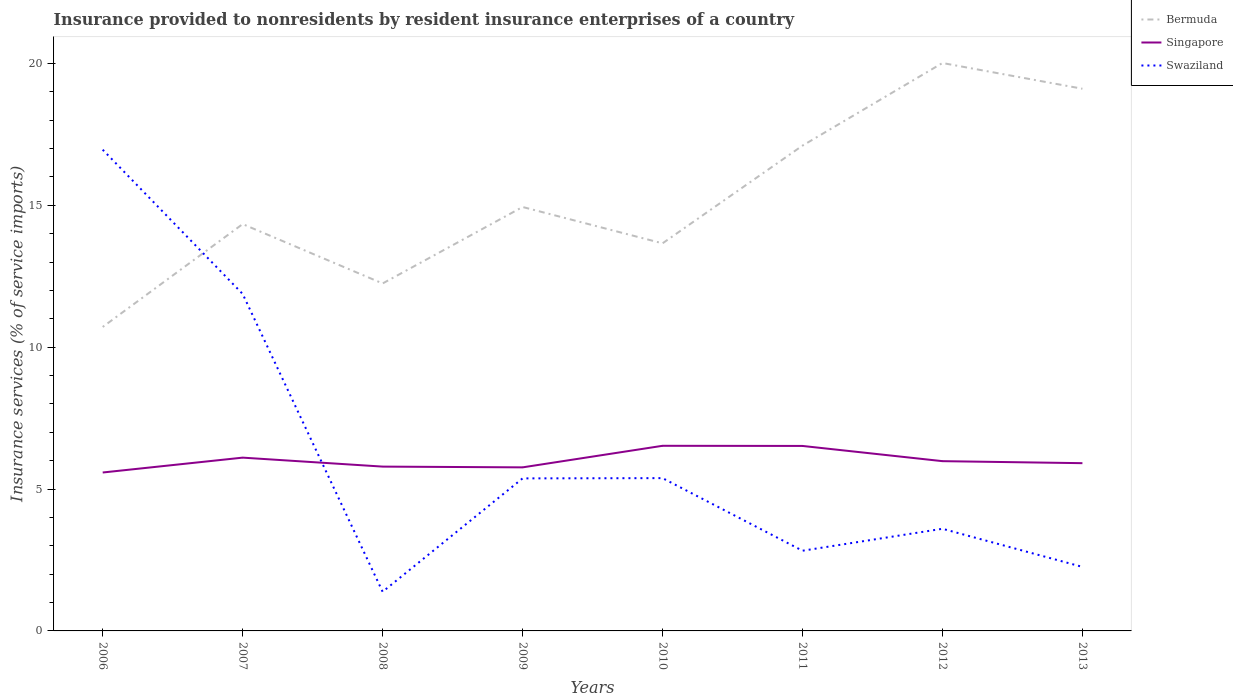Does the line corresponding to Singapore intersect with the line corresponding to Bermuda?
Offer a very short reply. No. Across all years, what is the maximum insurance provided to nonresidents in Singapore?
Offer a very short reply. 5.58. In which year was the insurance provided to nonresidents in Bermuda maximum?
Keep it short and to the point. 2006. What is the total insurance provided to nonresidents in Swaziland in the graph?
Provide a short and direct response. 2.56. What is the difference between the highest and the second highest insurance provided to nonresidents in Singapore?
Offer a very short reply. 0.94. What is the difference between the highest and the lowest insurance provided to nonresidents in Swaziland?
Your response must be concise. 2. How many lines are there?
Make the answer very short. 3. How many years are there in the graph?
Provide a succinct answer. 8. How many legend labels are there?
Your answer should be very brief. 3. How are the legend labels stacked?
Offer a very short reply. Vertical. What is the title of the graph?
Your response must be concise. Insurance provided to nonresidents by resident insurance enterprises of a country. What is the label or title of the X-axis?
Give a very brief answer. Years. What is the label or title of the Y-axis?
Your answer should be compact. Insurance services (% of service imports). What is the Insurance services (% of service imports) of Bermuda in 2006?
Keep it short and to the point. 10.71. What is the Insurance services (% of service imports) of Singapore in 2006?
Give a very brief answer. 5.58. What is the Insurance services (% of service imports) of Swaziland in 2006?
Your answer should be compact. 16.96. What is the Insurance services (% of service imports) in Bermuda in 2007?
Provide a succinct answer. 14.34. What is the Insurance services (% of service imports) of Singapore in 2007?
Keep it short and to the point. 6.11. What is the Insurance services (% of service imports) of Swaziland in 2007?
Offer a very short reply. 11.88. What is the Insurance services (% of service imports) in Bermuda in 2008?
Your answer should be very brief. 12.25. What is the Insurance services (% of service imports) in Singapore in 2008?
Keep it short and to the point. 5.79. What is the Insurance services (% of service imports) of Swaziland in 2008?
Offer a very short reply. 1.38. What is the Insurance services (% of service imports) in Bermuda in 2009?
Offer a terse response. 14.94. What is the Insurance services (% of service imports) in Singapore in 2009?
Your answer should be very brief. 5.76. What is the Insurance services (% of service imports) in Swaziland in 2009?
Provide a short and direct response. 5.38. What is the Insurance services (% of service imports) of Bermuda in 2010?
Give a very brief answer. 13.66. What is the Insurance services (% of service imports) in Singapore in 2010?
Your response must be concise. 6.52. What is the Insurance services (% of service imports) of Swaziland in 2010?
Offer a very short reply. 5.38. What is the Insurance services (% of service imports) in Bermuda in 2011?
Your response must be concise. 17.1. What is the Insurance services (% of service imports) of Singapore in 2011?
Your response must be concise. 6.52. What is the Insurance services (% of service imports) in Swaziland in 2011?
Your answer should be very brief. 2.83. What is the Insurance services (% of service imports) of Bermuda in 2012?
Your response must be concise. 20.02. What is the Insurance services (% of service imports) in Singapore in 2012?
Give a very brief answer. 5.98. What is the Insurance services (% of service imports) of Swaziland in 2012?
Ensure brevity in your answer.  3.6. What is the Insurance services (% of service imports) of Bermuda in 2013?
Your answer should be compact. 19.11. What is the Insurance services (% of service imports) in Singapore in 2013?
Provide a succinct answer. 5.91. What is the Insurance services (% of service imports) in Swaziland in 2013?
Give a very brief answer. 2.26. Across all years, what is the maximum Insurance services (% of service imports) of Bermuda?
Ensure brevity in your answer.  20.02. Across all years, what is the maximum Insurance services (% of service imports) of Singapore?
Provide a succinct answer. 6.52. Across all years, what is the maximum Insurance services (% of service imports) of Swaziland?
Give a very brief answer. 16.96. Across all years, what is the minimum Insurance services (% of service imports) in Bermuda?
Keep it short and to the point. 10.71. Across all years, what is the minimum Insurance services (% of service imports) in Singapore?
Your response must be concise. 5.58. Across all years, what is the minimum Insurance services (% of service imports) in Swaziland?
Ensure brevity in your answer.  1.38. What is the total Insurance services (% of service imports) in Bermuda in the graph?
Provide a short and direct response. 122.13. What is the total Insurance services (% of service imports) of Singapore in the graph?
Provide a succinct answer. 48.19. What is the total Insurance services (% of service imports) in Swaziland in the graph?
Keep it short and to the point. 49.66. What is the difference between the Insurance services (% of service imports) in Bermuda in 2006 and that in 2007?
Offer a very short reply. -3.62. What is the difference between the Insurance services (% of service imports) in Singapore in 2006 and that in 2007?
Your response must be concise. -0.52. What is the difference between the Insurance services (% of service imports) of Swaziland in 2006 and that in 2007?
Your response must be concise. 5.08. What is the difference between the Insurance services (% of service imports) in Bermuda in 2006 and that in 2008?
Keep it short and to the point. -1.53. What is the difference between the Insurance services (% of service imports) of Singapore in 2006 and that in 2008?
Your response must be concise. -0.21. What is the difference between the Insurance services (% of service imports) of Swaziland in 2006 and that in 2008?
Offer a very short reply. 15.58. What is the difference between the Insurance services (% of service imports) of Bermuda in 2006 and that in 2009?
Provide a succinct answer. -4.23. What is the difference between the Insurance services (% of service imports) in Singapore in 2006 and that in 2009?
Your response must be concise. -0.18. What is the difference between the Insurance services (% of service imports) of Swaziland in 2006 and that in 2009?
Your answer should be very brief. 11.58. What is the difference between the Insurance services (% of service imports) of Bermuda in 2006 and that in 2010?
Offer a very short reply. -2.95. What is the difference between the Insurance services (% of service imports) of Singapore in 2006 and that in 2010?
Make the answer very short. -0.94. What is the difference between the Insurance services (% of service imports) in Swaziland in 2006 and that in 2010?
Your answer should be very brief. 11.57. What is the difference between the Insurance services (% of service imports) in Bermuda in 2006 and that in 2011?
Provide a short and direct response. -6.39. What is the difference between the Insurance services (% of service imports) in Singapore in 2006 and that in 2011?
Make the answer very short. -0.94. What is the difference between the Insurance services (% of service imports) in Swaziland in 2006 and that in 2011?
Ensure brevity in your answer.  14.13. What is the difference between the Insurance services (% of service imports) in Bermuda in 2006 and that in 2012?
Your answer should be very brief. -9.3. What is the difference between the Insurance services (% of service imports) in Singapore in 2006 and that in 2012?
Your answer should be very brief. -0.4. What is the difference between the Insurance services (% of service imports) in Swaziland in 2006 and that in 2012?
Make the answer very short. 13.36. What is the difference between the Insurance services (% of service imports) in Bermuda in 2006 and that in 2013?
Offer a very short reply. -8.4. What is the difference between the Insurance services (% of service imports) in Singapore in 2006 and that in 2013?
Provide a succinct answer. -0.33. What is the difference between the Insurance services (% of service imports) of Swaziland in 2006 and that in 2013?
Your response must be concise. 14.7. What is the difference between the Insurance services (% of service imports) in Bermuda in 2007 and that in 2008?
Give a very brief answer. 2.09. What is the difference between the Insurance services (% of service imports) of Singapore in 2007 and that in 2008?
Your answer should be compact. 0.32. What is the difference between the Insurance services (% of service imports) of Swaziland in 2007 and that in 2008?
Provide a short and direct response. 10.5. What is the difference between the Insurance services (% of service imports) in Bermuda in 2007 and that in 2009?
Offer a very short reply. -0.6. What is the difference between the Insurance services (% of service imports) of Singapore in 2007 and that in 2009?
Your answer should be very brief. 0.34. What is the difference between the Insurance services (% of service imports) of Swaziland in 2007 and that in 2009?
Provide a succinct answer. 6.5. What is the difference between the Insurance services (% of service imports) of Bermuda in 2007 and that in 2010?
Offer a terse response. 0.68. What is the difference between the Insurance services (% of service imports) of Singapore in 2007 and that in 2010?
Your response must be concise. -0.42. What is the difference between the Insurance services (% of service imports) in Swaziland in 2007 and that in 2010?
Offer a terse response. 6.49. What is the difference between the Insurance services (% of service imports) in Bermuda in 2007 and that in 2011?
Give a very brief answer. -2.77. What is the difference between the Insurance services (% of service imports) of Singapore in 2007 and that in 2011?
Offer a terse response. -0.41. What is the difference between the Insurance services (% of service imports) in Swaziland in 2007 and that in 2011?
Offer a terse response. 9.05. What is the difference between the Insurance services (% of service imports) in Bermuda in 2007 and that in 2012?
Give a very brief answer. -5.68. What is the difference between the Insurance services (% of service imports) of Singapore in 2007 and that in 2012?
Make the answer very short. 0.12. What is the difference between the Insurance services (% of service imports) of Swaziland in 2007 and that in 2012?
Your answer should be compact. 8.28. What is the difference between the Insurance services (% of service imports) in Bermuda in 2007 and that in 2013?
Offer a very short reply. -4.77. What is the difference between the Insurance services (% of service imports) in Singapore in 2007 and that in 2013?
Your answer should be very brief. 0.2. What is the difference between the Insurance services (% of service imports) of Swaziland in 2007 and that in 2013?
Provide a short and direct response. 9.62. What is the difference between the Insurance services (% of service imports) of Bermuda in 2008 and that in 2009?
Offer a very short reply. -2.7. What is the difference between the Insurance services (% of service imports) of Singapore in 2008 and that in 2009?
Ensure brevity in your answer.  0.03. What is the difference between the Insurance services (% of service imports) of Swaziland in 2008 and that in 2009?
Provide a succinct answer. -4. What is the difference between the Insurance services (% of service imports) of Bermuda in 2008 and that in 2010?
Offer a terse response. -1.41. What is the difference between the Insurance services (% of service imports) of Singapore in 2008 and that in 2010?
Offer a terse response. -0.73. What is the difference between the Insurance services (% of service imports) of Swaziland in 2008 and that in 2010?
Give a very brief answer. -4. What is the difference between the Insurance services (% of service imports) in Bermuda in 2008 and that in 2011?
Provide a short and direct response. -4.86. What is the difference between the Insurance services (% of service imports) in Singapore in 2008 and that in 2011?
Make the answer very short. -0.73. What is the difference between the Insurance services (% of service imports) in Swaziland in 2008 and that in 2011?
Your answer should be compact. -1.45. What is the difference between the Insurance services (% of service imports) in Bermuda in 2008 and that in 2012?
Provide a succinct answer. -7.77. What is the difference between the Insurance services (% of service imports) in Singapore in 2008 and that in 2012?
Your response must be concise. -0.19. What is the difference between the Insurance services (% of service imports) in Swaziland in 2008 and that in 2012?
Ensure brevity in your answer.  -2.22. What is the difference between the Insurance services (% of service imports) of Bermuda in 2008 and that in 2013?
Ensure brevity in your answer.  -6.86. What is the difference between the Insurance services (% of service imports) in Singapore in 2008 and that in 2013?
Your answer should be compact. -0.12. What is the difference between the Insurance services (% of service imports) of Swaziland in 2008 and that in 2013?
Make the answer very short. -0.88. What is the difference between the Insurance services (% of service imports) of Bermuda in 2009 and that in 2010?
Provide a short and direct response. 1.28. What is the difference between the Insurance services (% of service imports) of Singapore in 2009 and that in 2010?
Offer a terse response. -0.76. What is the difference between the Insurance services (% of service imports) of Swaziland in 2009 and that in 2010?
Offer a very short reply. -0.01. What is the difference between the Insurance services (% of service imports) of Bermuda in 2009 and that in 2011?
Your answer should be compact. -2.16. What is the difference between the Insurance services (% of service imports) in Singapore in 2009 and that in 2011?
Your response must be concise. -0.75. What is the difference between the Insurance services (% of service imports) of Swaziland in 2009 and that in 2011?
Offer a terse response. 2.55. What is the difference between the Insurance services (% of service imports) of Bermuda in 2009 and that in 2012?
Offer a terse response. -5.07. What is the difference between the Insurance services (% of service imports) of Singapore in 2009 and that in 2012?
Your answer should be compact. -0.22. What is the difference between the Insurance services (% of service imports) in Swaziland in 2009 and that in 2012?
Your answer should be very brief. 1.78. What is the difference between the Insurance services (% of service imports) in Bermuda in 2009 and that in 2013?
Make the answer very short. -4.17. What is the difference between the Insurance services (% of service imports) in Singapore in 2009 and that in 2013?
Keep it short and to the point. -0.15. What is the difference between the Insurance services (% of service imports) of Swaziland in 2009 and that in 2013?
Offer a terse response. 3.12. What is the difference between the Insurance services (% of service imports) of Bermuda in 2010 and that in 2011?
Provide a short and direct response. -3.44. What is the difference between the Insurance services (% of service imports) of Singapore in 2010 and that in 2011?
Provide a short and direct response. 0.01. What is the difference between the Insurance services (% of service imports) of Swaziland in 2010 and that in 2011?
Ensure brevity in your answer.  2.56. What is the difference between the Insurance services (% of service imports) in Bermuda in 2010 and that in 2012?
Offer a terse response. -6.36. What is the difference between the Insurance services (% of service imports) in Singapore in 2010 and that in 2012?
Your response must be concise. 0.54. What is the difference between the Insurance services (% of service imports) in Swaziland in 2010 and that in 2012?
Provide a short and direct response. 1.78. What is the difference between the Insurance services (% of service imports) in Bermuda in 2010 and that in 2013?
Offer a very short reply. -5.45. What is the difference between the Insurance services (% of service imports) in Singapore in 2010 and that in 2013?
Ensure brevity in your answer.  0.61. What is the difference between the Insurance services (% of service imports) of Swaziland in 2010 and that in 2013?
Ensure brevity in your answer.  3.13. What is the difference between the Insurance services (% of service imports) in Bermuda in 2011 and that in 2012?
Your answer should be very brief. -2.91. What is the difference between the Insurance services (% of service imports) in Singapore in 2011 and that in 2012?
Provide a succinct answer. 0.54. What is the difference between the Insurance services (% of service imports) in Swaziland in 2011 and that in 2012?
Provide a succinct answer. -0.77. What is the difference between the Insurance services (% of service imports) of Bermuda in 2011 and that in 2013?
Offer a very short reply. -2. What is the difference between the Insurance services (% of service imports) of Singapore in 2011 and that in 2013?
Your answer should be very brief. 0.61. What is the difference between the Insurance services (% of service imports) of Swaziland in 2011 and that in 2013?
Offer a very short reply. 0.57. What is the difference between the Insurance services (% of service imports) of Bermuda in 2012 and that in 2013?
Ensure brevity in your answer.  0.91. What is the difference between the Insurance services (% of service imports) of Singapore in 2012 and that in 2013?
Your answer should be very brief. 0.07. What is the difference between the Insurance services (% of service imports) in Swaziland in 2012 and that in 2013?
Offer a terse response. 1.34. What is the difference between the Insurance services (% of service imports) of Bermuda in 2006 and the Insurance services (% of service imports) of Singapore in 2007?
Provide a succinct answer. 4.61. What is the difference between the Insurance services (% of service imports) in Bermuda in 2006 and the Insurance services (% of service imports) in Swaziland in 2007?
Your response must be concise. -1.16. What is the difference between the Insurance services (% of service imports) in Singapore in 2006 and the Insurance services (% of service imports) in Swaziland in 2007?
Your response must be concise. -6.29. What is the difference between the Insurance services (% of service imports) in Bermuda in 2006 and the Insurance services (% of service imports) in Singapore in 2008?
Provide a short and direct response. 4.92. What is the difference between the Insurance services (% of service imports) in Bermuda in 2006 and the Insurance services (% of service imports) in Swaziland in 2008?
Keep it short and to the point. 9.33. What is the difference between the Insurance services (% of service imports) of Singapore in 2006 and the Insurance services (% of service imports) of Swaziland in 2008?
Make the answer very short. 4.2. What is the difference between the Insurance services (% of service imports) of Bermuda in 2006 and the Insurance services (% of service imports) of Singapore in 2009?
Provide a short and direct response. 4.95. What is the difference between the Insurance services (% of service imports) of Bermuda in 2006 and the Insurance services (% of service imports) of Swaziland in 2009?
Offer a terse response. 5.34. What is the difference between the Insurance services (% of service imports) in Singapore in 2006 and the Insurance services (% of service imports) in Swaziland in 2009?
Ensure brevity in your answer.  0.21. What is the difference between the Insurance services (% of service imports) in Bermuda in 2006 and the Insurance services (% of service imports) in Singapore in 2010?
Your answer should be compact. 4.19. What is the difference between the Insurance services (% of service imports) in Bermuda in 2006 and the Insurance services (% of service imports) in Swaziland in 2010?
Provide a short and direct response. 5.33. What is the difference between the Insurance services (% of service imports) in Singapore in 2006 and the Insurance services (% of service imports) in Swaziland in 2010?
Ensure brevity in your answer.  0.2. What is the difference between the Insurance services (% of service imports) of Bermuda in 2006 and the Insurance services (% of service imports) of Singapore in 2011?
Your answer should be very brief. 4.19. What is the difference between the Insurance services (% of service imports) of Bermuda in 2006 and the Insurance services (% of service imports) of Swaziland in 2011?
Offer a very short reply. 7.89. What is the difference between the Insurance services (% of service imports) of Singapore in 2006 and the Insurance services (% of service imports) of Swaziland in 2011?
Your answer should be compact. 2.76. What is the difference between the Insurance services (% of service imports) of Bermuda in 2006 and the Insurance services (% of service imports) of Singapore in 2012?
Provide a short and direct response. 4.73. What is the difference between the Insurance services (% of service imports) in Bermuda in 2006 and the Insurance services (% of service imports) in Swaziland in 2012?
Make the answer very short. 7.11. What is the difference between the Insurance services (% of service imports) of Singapore in 2006 and the Insurance services (% of service imports) of Swaziland in 2012?
Give a very brief answer. 1.98. What is the difference between the Insurance services (% of service imports) in Bermuda in 2006 and the Insurance services (% of service imports) in Singapore in 2013?
Your answer should be very brief. 4.8. What is the difference between the Insurance services (% of service imports) in Bermuda in 2006 and the Insurance services (% of service imports) in Swaziland in 2013?
Provide a short and direct response. 8.46. What is the difference between the Insurance services (% of service imports) in Singapore in 2006 and the Insurance services (% of service imports) in Swaziland in 2013?
Make the answer very short. 3.33. What is the difference between the Insurance services (% of service imports) in Bermuda in 2007 and the Insurance services (% of service imports) in Singapore in 2008?
Provide a succinct answer. 8.55. What is the difference between the Insurance services (% of service imports) of Bermuda in 2007 and the Insurance services (% of service imports) of Swaziland in 2008?
Make the answer very short. 12.96. What is the difference between the Insurance services (% of service imports) of Singapore in 2007 and the Insurance services (% of service imports) of Swaziland in 2008?
Offer a very short reply. 4.73. What is the difference between the Insurance services (% of service imports) of Bermuda in 2007 and the Insurance services (% of service imports) of Singapore in 2009?
Offer a terse response. 8.57. What is the difference between the Insurance services (% of service imports) of Bermuda in 2007 and the Insurance services (% of service imports) of Swaziland in 2009?
Provide a succinct answer. 8.96. What is the difference between the Insurance services (% of service imports) of Singapore in 2007 and the Insurance services (% of service imports) of Swaziland in 2009?
Your answer should be compact. 0.73. What is the difference between the Insurance services (% of service imports) in Bermuda in 2007 and the Insurance services (% of service imports) in Singapore in 2010?
Offer a very short reply. 7.81. What is the difference between the Insurance services (% of service imports) in Bermuda in 2007 and the Insurance services (% of service imports) in Swaziland in 2010?
Ensure brevity in your answer.  8.95. What is the difference between the Insurance services (% of service imports) of Singapore in 2007 and the Insurance services (% of service imports) of Swaziland in 2010?
Your answer should be compact. 0.72. What is the difference between the Insurance services (% of service imports) of Bermuda in 2007 and the Insurance services (% of service imports) of Singapore in 2011?
Give a very brief answer. 7.82. What is the difference between the Insurance services (% of service imports) in Bermuda in 2007 and the Insurance services (% of service imports) in Swaziland in 2011?
Offer a terse response. 11.51. What is the difference between the Insurance services (% of service imports) of Singapore in 2007 and the Insurance services (% of service imports) of Swaziland in 2011?
Keep it short and to the point. 3.28. What is the difference between the Insurance services (% of service imports) of Bermuda in 2007 and the Insurance services (% of service imports) of Singapore in 2012?
Ensure brevity in your answer.  8.36. What is the difference between the Insurance services (% of service imports) in Bermuda in 2007 and the Insurance services (% of service imports) in Swaziland in 2012?
Provide a succinct answer. 10.74. What is the difference between the Insurance services (% of service imports) in Singapore in 2007 and the Insurance services (% of service imports) in Swaziland in 2012?
Your answer should be very brief. 2.51. What is the difference between the Insurance services (% of service imports) in Bermuda in 2007 and the Insurance services (% of service imports) in Singapore in 2013?
Make the answer very short. 8.43. What is the difference between the Insurance services (% of service imports) in Bermuda in 2007 and the Insurance services (% of service imports) in Swaziland in 2013?
Offer a terse response. 12.08. What is the difference between the Insurance services (% of service imports) of Singapore in 2007 and the Insurance services (% of service imports) of Swaziland in 2013?
Your answer should be very brief. 3.85. What is the difference between the Insurance services (% of service imports) of Bermuda in 2008 and the Insurance services (% of service imports) of Singapore in 2009?
Offer a very short reply. 6.48. What is the difference between the Insurance services (% of service imports) of Bermuda in 2008 and the Insurance services (% of service imports) of Swaziland in 2009?
Provide a short and direct response. 6.87. What is the difference between the Insurance services (% of service imports) of Singapore in 2008 and the Insurance services (% of service imports) of Swaziland in 2009?
Provide a succinct answer. 0.42. What is the difference between the Insurance services (% of service imports) in Bermuda in 2008 and the Insurance services (% of service imports) in Singapore in 2010?
Your response must be concise. 5.72. What is the difference between the Insurance services (% of service imports) of Bermuda in 2008 and the Insurance services (% of service imports) of Swaziland in 2010?
Keep it short and to the point. 6.86. What is the difference between the Insurance services (% of service imports) of Singapore in 2008 and the Insurance services (% of service imports) of Swaziland in 2010?
Ensure brevity in your answer.  0.41. What is the difference between the Insurance services (% of service imports) in Bermuda in 2008 and the Insurance services (% of service imports) in Singapore in 2011?
Your response must be concise. 5.73. What is the difference between the Insurance services (% of service imports) in Bermuda in 2008 and the Insurance services (% of service imports) in Swaziland in 2011?
Provide a short and direct response. 9.42. What is the difference between the Insurance services (% of service imports) in Singapore in 2008 and the Insurance services (% of service imports) in Swaziland in 2011?
Provide a succinct answer. 2.96. What is the difference between the Insurance services (% of service imports) of Bermuda in 2008 and the Insurance services (% of service imports) of Singapore in 2012?
Provide a succinct answer. 6.26. What is the difference between the Insurance services (% of service imports) of Bermuda in 2008 and the Insurance services (% of service imports) of Swaziland in 2012?
Make the answer very short. 8.65. What is the difference between the Insurance services (% of service imports) in Singapore in 2008 and the Insurance services (% of service imports) in Swaziland in 2012?
Ensure brevity in your answer.  2.19. What is the difference between the Insurance services (% of service imports) of Bermuda in 2008 and the Insurance services (% of service imports) of Singapore in 2013?
Give a very brief answer. 6.33. What is the difference between the Insurance services (% of service imports) in Bermuda in 2008 and the Insurance services (% of service imports) in Swaziland in 2013?
Give a very brief answer. 9.99. What is the difference between the Insurance services (% of service imports) in Singapore in 2008 and the Insurance services (% of service imports) in Swaziland in 2013?
Provide a succinct answer. 3.53. What is the difference between the Insurance services (% of service imports) in Bermuda in 2009 and the Insurance services (% of service imports) in Singapore in 2010?
Provide a succinct answer. 8.42. What is the difference between the Insurance services (% of service imports) of Bermuda in 2009 and the Insurance services (% of service imports) of Swaziland in 2010?
Your answer should be very brief. 9.56. What is the difference between the Insurance services (% of service imports) of Singapore in 2009 and the Insurance services (% of service imports) of Swaziland in 2010?
Offer a very short reply. 0.38. What is the difference between the Insurance services (% of service imports) of Bermuda in 2009 and the Insurance services (% of service imports) of Singapore in 2011?
Provide a short and direct response. 8.42. What is the difference between the Insurance services (% of service imports) in Bermuda in 2009 and the Insurance services (% of service imports) in Swaziland in 2011?
Your answer should be very brief. 12.11. What is the difference between the Insurance services (% of service imports) of Singapore in 2009 and the Insurance services (% of service imports) of Swaziland in 2011?
Make the answer very short. 2.94. What is the difference between the Insurance services (% of service imports) in Bermuda in 2009 and the Insurance services (% of service imports) in Singapore in 2012?
Offer a very short reply. 8.96. What is the difference between the Insurance services (% of service imports) of Bermuda in 2009 and the Insurance services (% of service imports) of Swaziland in 2012?
Keep it short and to the point. 11.34. What is the difference between the Insurance services (% of service imports) of Singapore in 2009 and the Insurance services (% of service imports) of Swaziland in 2012?
Offer a terse response. 2.16. What is the difference between the Insurance services (% of service imports) of Bermuda in 2009 and the Insurance services (% of service imports) of Singapore in 2013?
Ensure brevity in your answer.  9.03. What is the difference between the Insurance services (% of service imports) in Bermuda in 2009 and the Insurance services (% of service imports) in Swaziland in 2013?
Your answer should be very brief. 12.68. What is the difference between the Insurance services (% of service imports) of Singapore in 2009 and the Insurance services (% of service imports) of Swaziland in 2013?
Ensure brevity in your answer.  3.51. What is the difference between the Insurance services (% of service imports) of Bermuda in 2010 and the Insurance services (% of service imports) of Singapore in 2011?
Give a very brief answer. 7.14. What is the difference between the Insurance services (% of service imports) in Bermuda in 2010 and the Insurance services (% of service imports) in Swaziland in 2011?
Give a very brief answer. 10.83. What is the difference between the Insurance services (% of service imports) in Singapore in 2010 and the Insurance services (% of service imports) in Swaziland in 2011?
Offer a terse response. 3.7. What is the difference between the Insurance services (% of service imports) in Bermuda in 2010 and the Insurance services (% of service imports) in Singapore in 2012?
Your response must be concise. 7.68. What is the difference between the Insurance services (% of service imports) of Bermuda in 2010 and the Insurance services (% of service imports) of Swaziland in 2012?
Your answer should be compact. 10.06. What is the difference between the Insurance services (% of service imports) in Singapore in 2010 and the Insurance services (% of service imports) in Swaziland in 2012?
Provide a short and direct response. 2.92. What is the difference between the Insurance services (% of service imports) of Bermuda in 2010 and the Insurance services (% of service imports) of Singapore in 2013?
Keep it short and to the point. 7.75. What is the difference between the Insurance services (% of service imports) in Bermuda in 2010 and the Insurance services (% of service imports) in Swaziland in 2013?
Provide a succinct answer. 11.4. What is the difference between the Insurance services (% of service imports) in Singapore in 2010 and the Insurance services (% of service imports) in Swaziland in 2013?
Your response must be concise. 4.27. What is the difference between the Insurance services (% of service imports) of Bermuda in 2011 and the Insurance services (% of service imports) of Singapore in 2012?
Your answer should be compact. 11.12. What is the difference between the Insurance services (% of service imports) of Bermuda in 2011 and the Insurance services (% of service imports) of Swaziland in 2012?
Your response must be concise. 13.5. What is the difference between the Insurance services (% of service imports) in Singapore in 2011 and the Insurance services (% of service imports) in Swaziland in 2012?
Your answer should be very brief. 2.92. What is the difference between the Insurance services (% of service imports) in Bermuda in 2011 and the Insurance services (% of service imports) in Singapore in 2013?
Your answer should be very brief. 11.19. What is the difference between the Insurance services (% of service imports) of Bermuda in 2011 and the Insurance services (% of service imports) of Swaziland in 2013?
Offer a very short reply. 14.85. What is the difference between the Insurance services (% of service imports) of Singapore in 2011 and the Insurance services (% of service imports) of Swaziland in 2013?
Your response must be concise. 4.26. What is the difference between the Insurance services (% of service imports) in Bermuda in 2012 and the Insurance services (% of service imports) in Singapore in 2013?
Your answer should be very brief. 14.1. What is the difference between the Insurance services (% of service imports) in Bermuda in 2012 and the Insurance services (% of service imports) in Swaziland in 2013?
Your answer should be compact. 17.76. What is the difference between the Insurance services (% of service imports) of Singapore in 2012 and the Insurance services (% of service imports) of Swaziland in 2013?
Make the answer very short. 3.73. What is the average Insurance services (% of service imports) of Bermuda per year?
Your response must be concise. 15.27. What is the average Insurance services (% of service imports) of Singapore per year?
Offer a terse response. 6.02. What is the average Insurance services (% of service imports) of Swaziland per year?
Your response must be concise. 6.21. In the year 2006, what is the difference between the Insurance services (% of service imports) in Bermuda and Insurance services (% of service imports) in Singapore?
Provide a short and direct response. 5.13. In the year 2006, what is the difference between the Insurance services (% of service imports) in Bermuda and Insurance services (% of service imports) in Swaziland?
Your answer should be very brief. -6.25. In the year 2006, what is the difference between the Insurance services (% of service imports) in Singapore and Insurance services (% of service imports) in Swaziland?
Your response must be concise. -11.38. In the year 2007, what is the difference between the Insurance services (% of service imports) of Bermuda and Insurance services (% of service imports) of Singapore?
Your answer should be compact. 8.23. In the year 2007, what is the difference between the Insurance services (% of service imports) of Bermuda and Insurance services (% of service imports) of Swaziland?
Your answer should be very brief. 2.46. In the year 2007, what is the difference between the Insurance services (% of service imports) of Singapore and Insurance services (% of service imports) of Swaziland?
Your answer should be compact. -5.77. In the year 2008, what is the difference between the Insurance services (% of service imports) of Bermuda and Insurance services (% of service imports) of Singapore?
Your response must be concise. 6.45. In the year 2008, what is the difference between the Insurance services (% of service imports) of Bermuda and Insurance services (% of service imports) of Swaziland?
Give a very brief answer. 10.87. In the year 2008, what is the difference between the Insurance services (% of service imports) of Singapore and Insurance services (% of service imports) of Swaziland?
Offer a very short reply. 4.41. In the year 2009, what is the difference between the Insurance services (% of service imports) in Bermuda and Insurance services (% of service imports) in Singapore?
Offer a terse response. 9.18. In the year 2009, what is the difference between the Insurance services (% of service imports) of Bermuda and Insurance services (% of service imports) of Swaziland?
Your answer should be very brief. 9.57. In the year 2009, what is the difference between the Insurance services (% of service imports) of Singapore and Insurance services (% of service imports) of Swaziland?
Ensure brevity in your answer.  0.39. In the year 2010, what is the difference between the Insurance services (% of service imports) of Bermuda and Insurance services (% of service imports) of Singapore?
Provide a short and direct response. 7.14. In the year 2010, what is the difference between the Insurance services (% of service imports) in Bermuda and Insurance services (% of service imports) in Swaziland?
Provide a short and direct response. 8.28. In the year 2010, what is the difference between the Insurance services (% of service imports) of Singapore and Insurance services (% of service imports) of Swaziland?
Your response must be concise. 1.14. In the year 2011, what is the difference between the Insurance services (% of service imports) of Bermuda and Insurance services (% of service imports) of Singapore?
Ensure brevity in your answer.  10.58. In the year 2011, what is the difference between the Insurance services (% of service imports) of Bermuda and Insurance services (% of service imports) of Swaziland?
Offer a very short reply. 14.28. In the year 2011, what is the difference between the Insurance services (% of service imports) in Singapore and Insurance services (% of service imports) in Swaziland?
Make the answer very short. 3.69. In the year 2012, what is the difference between the Insurance services (% of service imports) of Bermuda and Insurance services (% of service imports) of Singapore?
Keep it short and to the point. 14.03. In the year 2012, what is the difference between the Insurance services (% of service imports) of Bermuda and Insurance services (% of service imports) of Swaziland?
Keep it short and to the point. 16.41. In the year 2012, what is the difference between the Insurance services (% of service imports) in Singapore and Insurance services (% of service imports) in Swaziland?
Provide a succinct answer. 2.38. In the year 2013, what is the difference between the Insurance services (% of service imports) of Bermuda and Insurance services (% of service imports) of Singapore?
Offer a terse response. 13.2. In the year 2013, what is the difference between the Insurance services (% of service imports) in Bermuda and Insurance services (% of service imports) in Swaziland?
Offer a terse response. 16.85. In the year 2013, what is the difference between the Insurance services (% of service imports) in Singapore and Insurance services (% of service imports) in Swaziland?
Keep it short and to the point. 3.66. What is the ratio of the Insurance services (% of service imports) of Bermuda in 2006 to that in 2007?
Give a very brief answer. 0.75. What is the ratio of the Insurance services (% of service imports) of Singapore in 2006 to that in 2007?
Keep it short and to the point. 0.91. What is the ratio of the Insurance services (% of service imports) in Swaziland in 2006 to that in 2007?
Make the answer very short. 1.43. What is the ratio of the Insurance services (% of service imports) in Bermuda in 2006 to that in 2008?
Provide a short and direct response. 0.87. What is the ratio of the Insurance services (% of service imports) in Singapore in 2006 to that in 2008?
Keep it short and to the point. 0.96. What is the ratio of the Insurance services (% of service imports) in Swaziland in 2006 to that in 2008?
Offer a terse response. 12.29. What is the ratio of the Insurance services (% of service imports) of Bermuda in 2006 to that in 2009?
Offer a very short reply. 0.72. What is the ratio of the Insurance services (% of service imports) of Singapore in 2006 to that in 2009?
Your answer should be compact. 0.97. What is the ratio of the Insurance services (% of service imports) in Swaziland in 2006 to that in 2009?
Your response must be concise. 3.15. What is the ratio of the Insurance services (% of service imports) in Bermuda in 2006 to that in 2010?
Your answer should be very brief. 0.78. What is the ratio of the Insurance services (% of service imports) of Singapore in 2006 to that in 2010?
Offer a terse response. 0.86. What is the ratio of the Insurance services (% of service imports) of Swaziland in 2006 to that in 2010?
Your answer should be very brief. 3.15. What is the ratio of the Insurance services (% of service imports) of Bermuda in 2006 to that in 2011?
Offer a very short reply. 0.63. What is the ratio of the Insurance services (% of service imports) in Singapore in 2006 to that in 2011?
Offer a very short reply. 0.86. What is the ratio of the Insurance services (% of service imports) of Swaziland in 2006 to that in 2011?
Your answer should be very brief. 6. What is the ratio of the Insurance services (% of service imports) of Bermuda in 2006 to that in 2012?
Your answer should be compact. 0.54. What is the ratio of the Insurance services (% of service imports) of Singapore in 2006 to that in 2012?
Keep it short and to the point. 0.93. What is the ratio of the Insurance services (% of service imports) of Swaziland in 2006 to that in 2012?
Ensure brevity in your answer.  4.71. What is the ratio of the Insurance services (% of service imports) of Bermuda in 2006 to that in 2013?
Make the answer very short. 0.56. What is the ratio of the Insurance services (% of service imports) in Swaziland in 2006 to that in 2013?
Offer a very short reply. 7.52. What is the ratio of the Insurance services (% of service imports) of Bermuda in 2007 to that in 2008?
Ensure brevity in your answer.  1.17. What is the ratio of the Insurance services (% of service imports) of Singapore in 2007 to that in 2008?
Ensure brevity in your answer.  1.05. What is the ratio of the Insurance services (% of service imports) of Swaziland in 2007 to that in 2008?
Your response must be concise. 8.6. What is the ratio of the Insurance services (% of service imports) in Bermuda in 2007 to that in 2009?
Provide a short and direct response. 0.96. What is the ratio of the Insurance services (% of service imports) in Singapore in 2007 to that in 2009?
Offer a terse response. 1.06. What is the ratio of the Insurance services (% of service imports) in Swaziland in 2007 to that in 2009?
Keep it short and to the point. 2.21. What is the ratio of the Insurance services (% of service imports) of Bermuda in 2007 to that in 2010?
Offer a very short reply. 1.05. What is the ratio of the Insurance services (% of service imports) in Singapore in 2007 to that in 2010?
Offer a terse response. 0.94. What is the ratio of the Insurance services (% of service imports) in Swaziland in 2007 to that in 2010?
Ensure brevity in your answer.  2.21. What is the ratio of the Insurance services (% of service imports) in Bermuda in 2007 to that in 2011?
Provide a succinct answer. 0.84. What is the ratio of the Insurance services (% of service imports) of Singapore in 2007 to that in 2011?
Make the answer very short. 0.94. What is the ratio of the Insurance services (% of service imports) of Swaziland in 2007 to that in 2011?
Provide a succinct answer. 4.2. What is the ratio of the Insurance services (% of service imports) of Bermuda in 2007 to that in 2012?
Offer a terse response. 0.72. What is the ratio of the Insurance services (% of service imports) of Singapore in 2007 to that in 2012?
Ensure brevity in your answer.  1.02. What is the ratio of the Insurance services (% of service imports) in Swaziland in 2007 to that in 2012?
Your response must be concise. 3.3. What is the ratio of the Insurance services (% of service imports) of Bermuda in 2007 to that in 2013?
Provide a succinct answer. 0.75. What is the ratio of the Insurance services (% of service imports) of Singapore in 2007 to that in 2013?
Make the answer very short. 1.03. What is the ratio of the Insurance services (% of service imports) of Swaziland in 2007 to that in 2013?
Offer a terse response. 5.26. What is the ratio of the Insurance services (% of service imports) in Bermuda in 2008 to that in 2009?
Keep it short and to the point. 0.82. What is the ratio of the Insurance services (% of service imports) in Swaziland in 2008 to that in 2009?
Offer a terse response. 0.26. What is the ratio of the Insurance services (% of service imports) in Bermuda in 2008 to that in 2010?
Provide a short and direct response. 0.9. What is the ratio of the Insurance services (% of service imports) in Singapore in 2008 to that in 2010?
Offer a terse response. 0.89. What is the ratio of the Insurance services (% of service imports) in Swaziland in 2008 to that in 2010?
Make the answer very short. 0.26. What is the ratio of the Insurance services (% of service imports) in Bermuda in 2008 to that in 2011?
Keep it short and to the point. 0.72. What is the ratio of the Insurance services (% of service imports) of Singapore in 2008 to that in 2011?
Give a very brief answer. 0.89. What is the ratio of the Insurance services (% of service imports) of Swaziland in 2008 to that in 2011?
Your response must be concise. 0.49. What is the ratio of the Insurance services (% of service imports) in Bermuda in 2008 to that in 2012?
Your response must be concise. 0.61. What is the ratio of the Insurance services (% of service imports) of Singapore in 2008 to that in 2012?
Your answer should be compact. 0.97. What is the ratio of the Insurance services (% of service imports) of Swaziland in 2008 to that in 2012?
Keep it short and to the point. 0.38. What is the ratio of the Insurance services (% of service imports) of Bermuda in 2008 to that in 2013?
Provide a short and direct response. 0.64. What is the ratio of the Insurance services (% of service imports) in Singapore in 2008 to that in 2013?
Offer a very short reply. 0.98. What is the ratio of the Insurance services (% of service imports) of Swaziland in 2008 to that in 2013?
Provide a succinct answer. 0.61. What is the ratio of the Insurance services (% of service imports) in Bermuda in 2009 to that in 2010?
Offer a very short reply. 1.09. What is the ratio of the Insurance services (% of service imports) of Singapore in 2009 to that in 2010?
Your response must be concise. 0.88. What is the ratio of the Insurance services (% of service imports) in Swaziland in 2009 to that in 2010?
Make the answer very short. 1. What is the ratio of the Insurance services (% of service imports) of Bermuda in 2009 to that in 2011?
Provide a short and direct response. 0.87. What is the ratio of the Insurance services (% of service imports) of Singapore in 2009 to that in 2011?
Make the answer very short. 0.88. What is the ratio of the Insurance services (% of service imports) of Swaziland in 2009 to that in 2011?
Offer a terse response. 1.9. What is the ratio of the Insurance services (% of service imports) in Bermuda in 2009 to that in 2012?
Your answer should be very brief. 0.75. What is the ratio of the Insurance services (% of service imports) in Singapore in 2009 to that in 2012?
Give a very brief answer. 0.96. What is the ratio of the Insurance services (% of service imports) in Swaziland in 2009 to that in 2012?
Provide a succinct answer. 1.49. What is the ratio of the Insurance services (% of service imports) in Bermuda in 2009 to that in 2013?
Your response must be concise. 0.78. What is the ratio of the Insurance services (% of service imports) of Swaziland in 2009 to that in 2013?
Ensure brevity in your answer.  2.38. What is the ratio of the Insurance services (% of service imports) in Bermuda in 2010 to that in 2011?
Provide a short and direct response. 0.8. What is the ratio of the Insurance services (% of service imports) of Singapore in 2010 to that in 2011?
Provide a short and direct response. 1. What is the ratio of the Insurance services (% of service imports) in Swaziland in 2010 to that in 2011?
Your answer should be very brief. 1.91. What is the ratio of the Insurance services (% of service imports) of Bermuda in 2010 to that in 2012?
Provide a succinct answer. 0.68. What is the ratio of the Insurance services (% of service imports) of Singapore in 2010 to that in 2012?
Offer a terse response. 1.09. What is the ratio of the Insurance services (% of service imports) in Swaziland in 2010 to that in 2012?
Make the answer very short. 1.5. What is the ratio of the Insurance services (% of service imports) of Bermuda in 2010 to that in 2013?
Provide a succinct answer. 0.71. What is the ratio of the Insurance services (% of service imports) of Singapore in 2010 to that in 2013?
Make the answer very short. 1.1. What is the ratio of the Insurance services (% of service imports) of Swaziland in 2010 to that in 2013?
Give a very brief answer. 2.39. What is the ratio of the Insurance services (% of service imports) of Bermuda in 2011 to that in 2012?
Keep it short and to the point. 0.85. What is the ratio of the Insurance services (% of service imports) in Singapore in 2011 to that in 2012?
Your answer should be compact. 1.09. What is the ratio of the Insurance services (% of service imports) of Swaziland in 2011 to that in 2012?
Provide a short and direct response. 0.79. What is the ratio of the Insurance services (% of service imports) in Bermuda in 2011 to that in 2013?
Make the answer very short. 0.9. What is the ratio of the Insurance services (% of service imports) of Singapore in 2011 to that in 2013?
Provide a succinct answer. 1.1. What is the ratio of the Insurance services (% of service imports) of Swaziland in 2011 to that in 2013?
Keep it short and to the point. 1.25. What is the ratio of the Insurance services (% of service imports) of Bermuda in 2012 to that in 2013?
Offer a terse response. 1.05. What is the ratio of the Insurance services (% of service imports) in Swaziland in 2012 to that in 2013?
Keep it short and to the point. 1.6. What is the difference between the highest and the second highest Insurance services (% of service imports) in Bermuda?
Provide a short and direct response. 0.91. What is the difference between the highest and the second highest Insurance services (% of service imports) in Singapore?
Your answer should be very brief. 0.01. What is the difference between the highest and the second highest Insurance services (% of service imports) in Swaziland?
Offer a terse response. 5.08. What is the difference between the highest and the lowest Insurance services (% of service imports) in Bermuda?
Provide a short and direct response. 9.3. What is the difference between the highest and the lowest Insurance services (% of service imports) of Swaziland?
Offer a terse response. 15.58. 